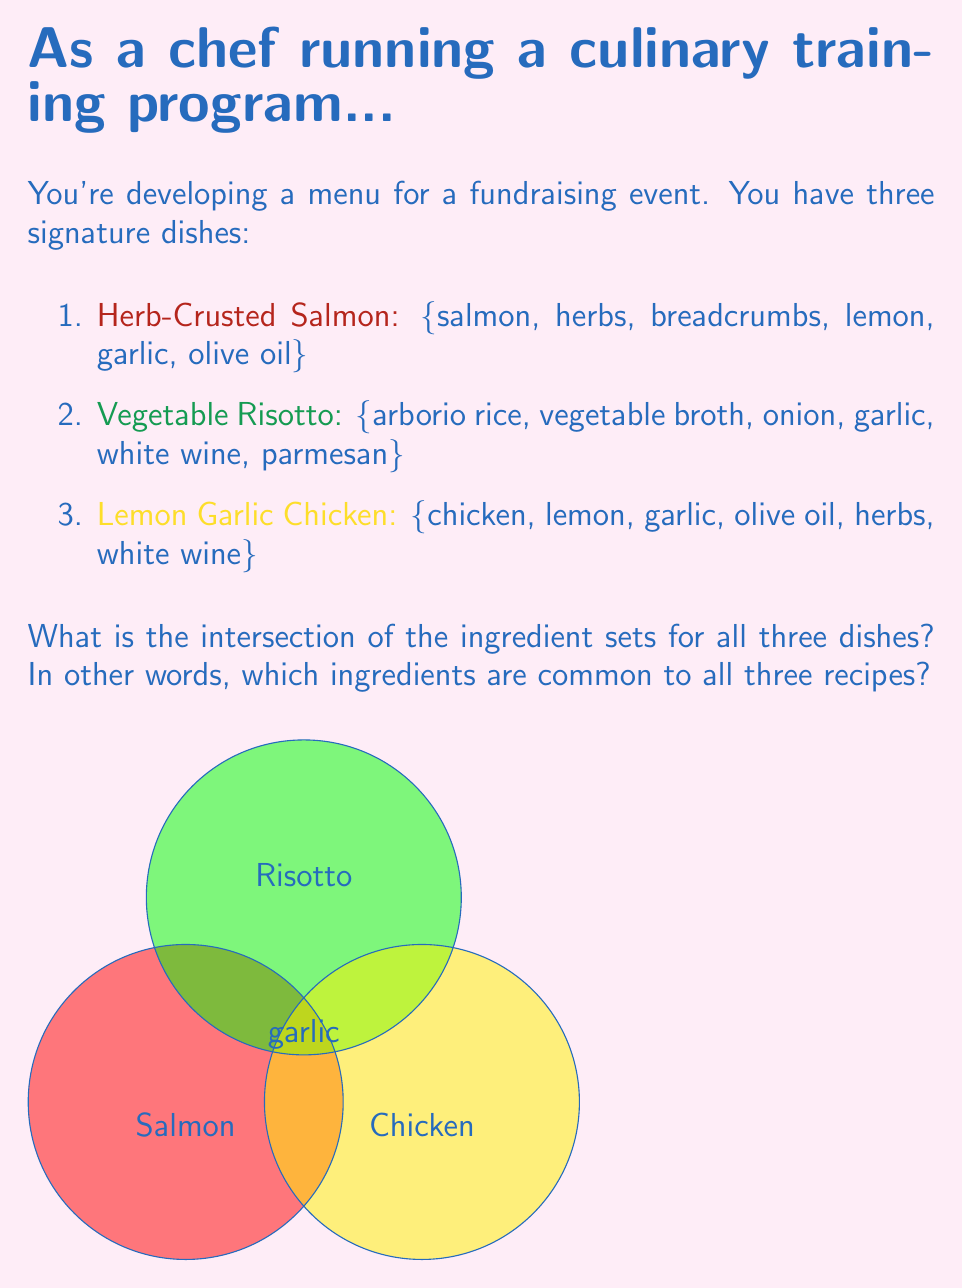What is the answer to this math problem? To find the intersection of the ingredient sets for all three dishes, we need to identify the ingredients that appear in every set. Let's approach this step-by-step:

1. First, let's define our sets:
   $$S = \{\text{salmon, herbs, breadcrumbs, lemon, garlic, olive oil}\}$$
   $$R = \{\text{arborio rice, vegetable broth, onion, garlic, white wine, parmesan}\}$$
   $$C = \{\text{chicken, lemon, garlic, olive oil, herbs, white wine}\}$$

2. We're looking for the intersection of all three sets, which in set notation is:
   $$S \cap R \cap C$$

3. To find this, we can go through each ingredient and check if it appears in all three sets:

   - salmon: only in S
   - herbs: in S and C, but not R
   - breadcrumbs: only in S
   - lemon: in S and C, but not R
   - garlic: in S, R, and C ✓
   - olive oil: in S and C, but not R
   - arborio rice: only in R
   - vegetable broth: only in R
   - onion: only in R
   - white wine: in R and C, but not S
   - parmesan: only in R
   - chicken: only in C

4. We can see that the only ingredient that appears in all three sets is garlic.

Therefore, the intersection of all three sets contains only one element: garlic.
Answer: $\{garlic\}$ 